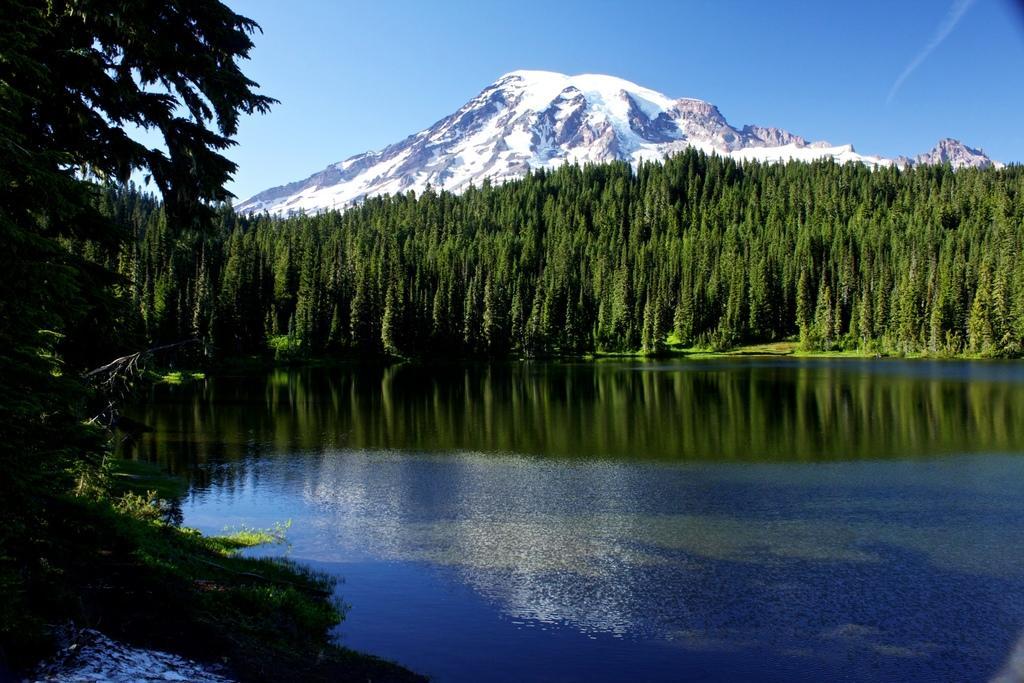Can you describe this image briefly? In this picture we can observe a lake. There are some trees. In the background we can observe a hill with some snow on the hill. In the background there is a sky. 